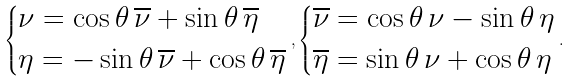<formula> <loc_0><loc_0><loc_500><loc_500>\begin{dcases} \nu = \cos \theta \, \overline { \nu } + \sin \theta \, \overline { \eta } \\ \eta = - \sin \theta \, \overline { \nu } + \cos \theta \, \overline { \eta } \end{dcases} , \begin{dcases} \overline { \nu } = \cos \theta \, \nu - \sin \theta \, \eta \\ \overline { \eta } = \sin \theta \, \nu + \cos \theta \, \eta \end{dcases} .</formula> 